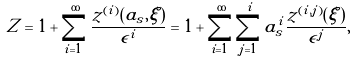<formula> <loc_0><loc_0><loc_500><loc_500>Z = 1 + \sum _ { i = 1 } ^ { \infty } \frac { z ^ { ( i ) } ( a _ { s } , \xi ) } { \epsilon ^ { i } } = 1 + \sum _ { i = 1 } ^ { \infty } \sum _ { j = 1 } ^ { i } a _ { s } ^ { i } \frac { z ^ { ( i , j ) } ( \xi ) } { \epsilon ^ { j } } ,</formula> 